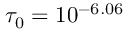<formula> <loc_0><loc_0><loc_500><loc_500>\tau _ { 0 } = 1 0 ^ { - 6 . 0 6 }</formula> 